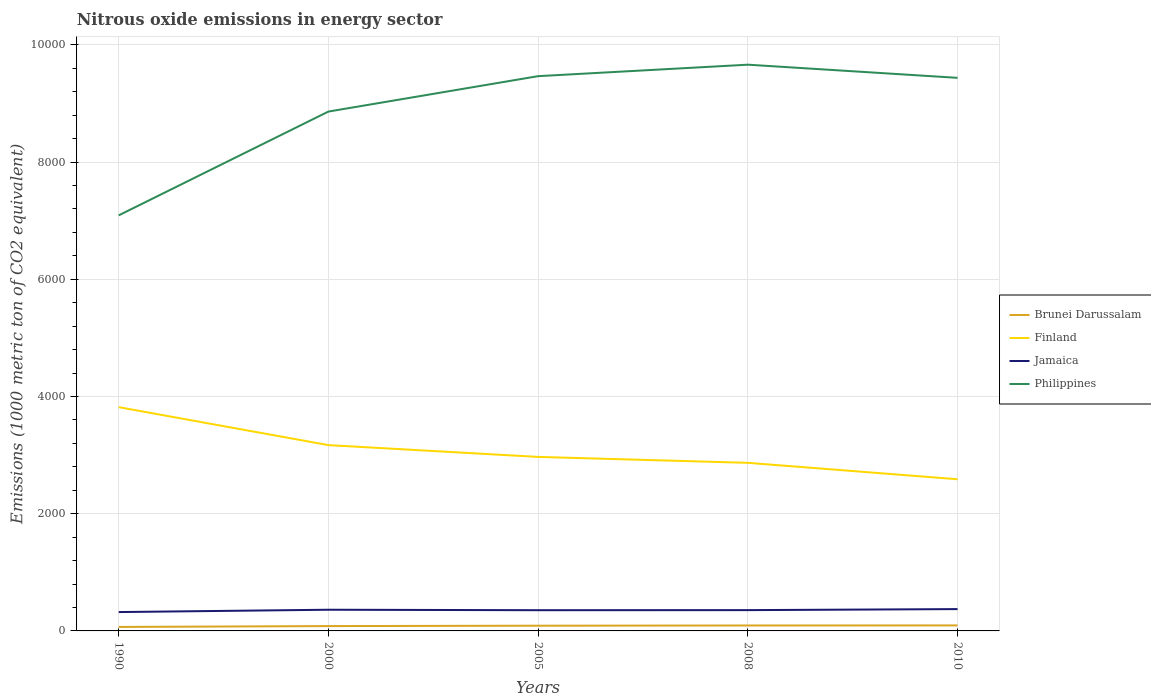Does the line corresponding to Jamaica intersect with the line corresponding to Philippines?
Offer a very short reply. No. Across all years, what is the maximum amount of nitrous oxide emitted in Philippines?
Your answer should be very brief. 7090.2. In which year was the amount of nitrous oxide emitted in Philippines maximum?
Make the answer very short. 1990. What is the total amount of nitrous oxide emitted in Philippines in the graph?
Your answer should be very brief. -1770.9. What is the difference between the highest and the second highest amount of nitrous oxide emitted in Brunei Darussalam?
Give a very brief answer. 26.2. What is the difference between the highest and the lowest amount of nitrous oxide emitted in Philippines?
Your answer should be very brief. 3. Is the amount of nitrous oxide emitted in Jamaica strictly greater than the amount of nitrous oxide emitted in Finland over the years?
Provide a short and direct response. Yes. How many lines are there?
Give a very brief answer. 4. What is the difference between two consecutive major ticks on the Y-axis?
Offer a very short reply. 2000. Does the graph contain grids?
Keep it short and to the point. Yes. How many legend labels are there?
Your answer should be compact. 4. What is the title of the graph?
Ensure brevity in your answer.  Nitrous oxide emissions in energy sector. What is the label or title of the Y-axis?
Your answer should be very brief. Emissions (1000 metric ton of CO2 equivalent). What is the Emissions (1000 metric ton of CO2 equivalent) of Brunei Darussalam in 1990?
Ensure brevity in your answer.  67.9. What is the Emissions (1000 metric ton of CO2 equivalent) in Finland in 1990?
Offer a terse response. 3817.9. What is the Emissions (1000 metric ton of CO2 equivalent) in Jamaica in 1990?
Your answer should be very brief. 321.7. What is the Emissions (1000 metric ton of CO2 equivalent) in Philippines in 1990?
Your response must be concise. 7090.2. What is the Emissions (1000 metric ton of CO2 equivalent) in Brunei Darussalam in 2000?
Your answer should be compact. 82.7. What is the Emissions (1000 metric ton of CO2 equivalent) of Finland in 2000?
Your answer should be very brief. 3169.9. What is the Emissions (1000 metric ton of CO2 equivalent) in Jamaica in 2000?
Your answer should be very brief. 361.6. What is the Emissions (1000 metric ton of CO2 equivalent) in Philippines in 2000?
Your answer should be compact. 8861.1. What is the Emissions (1000 metric ton of CO2 equivalent) in Brunei Darussalam in 2005?
Provide a short and direct response. 88.9. What is the Emissions (1000 metric ton of CO2 equivalent) in Finland in 2005?
Make the answer very short. 2969. What is the Emissions (1000 metric ton of CO2 equivalent) in Jamaica in 2005?
Your answer should be compact. 353.5. What is the Emissions (1000 metric ton of CO2 equivalent) in Philippines in 2005?
Your response must be concise. 9465.1. What is the Emissions (1000 metric ton of CO2 equivalent) of Brunei Darussalam in 2008?
Provide a short and direct response. 92.7. What is the Emissions (1000 metric ton of CO2 equivalent) of Finland in 2008?
Provide a succinct answer. 2868. What is the Emissions (1000 metric ton of CO2 equivalent) of Jamaica in 2008?
Provide a succinct answer. 354.8. What is the Emissions (1000 metric ton of CO2 equivalent) in Philippines in 2008?
Keep it short and to the point. 9660.8. What is the Emissions (1000 metric ton of CO2 equivalent) of Brunei Darussalam in 2010?
Offer a very short reply. 94.1. What is the Emissions (1000 metric ton of CO2 equivalent) in Finland in 2010?
Ensure brevity in your answer.  2587.6. What is the Emissions (1000 metric ton of CO2 equivalent) of Jamaica in 2010?
Offer a very short reply. 372.5. What is the Emissions (1000 metric ton of CO2 equivalent) in Philippines in 2010?
Provide a short and direct response. 9436.4. Across all years, what is the maximum Emissions (1000 metric ton of CO2 equivalent) of Brunei Darussalam?
Give a very brief answer. 94.1. Across all years, what is the maximum Emissions (1000 metric ton of CO2 equivalent) in Finland?
Provide a short and direct response. 3817.9. Across all years, what is the maximum Emissions (1000 metric ton of CO2 equivalent) in Jamaica?
Your response must be concise. 372.5. Across all years, what is the maximum Emissions (1000 metric ton of CO2 equivalent) of Philippines?
Your response must be concise. 9660.8. Across all years, what is the minimum Emissions (1000 metric ton of CO2 equivalent) in Brunei Darussalam?
Give a very brief answer. 67.9. Across all years, what is the minimum Emissions (1000 metric ton of CO2 equivalent) in Finland?
Provide a short and direct response. 2587.6. Across all years, what is the minimum Emissions (1000 metric ton of CO2 equivalent) of Jamaica?
Ensure brevity in your answer.  321.7. Across all years, what is the minimum Emissions (1000 metric ton of CO2 equivalent) in Philippines?
Offer a very short reply. 7090.2. What is the total Emissions (1000 metric ton of CO2 equivalent) of Brunei Darussalam in the graph?
Your answer should be compact. 426.3. What is the total Emissions (1000 metric ton of CO2 equivalent) of Finland in the graph?
Your response must be concise. 1.54e+04. What is the total Emissions (1000 metric ton of CO2 equivalent) of Jamaica in the graph?
Provide a short and direct response. 1764.1. What is the total Emissions (1000 metric ton of CO2 equivalent) of Philippines in the graph?
Ensure brevity in your answer.  4.45e+04. What is the difference between the Emissions (1000 metric ton of CO2 equivalent) in Brunei Darussalam in 1990 and that in 2000?
Keep it short and to the point. -14.8. What is the difference between the Emissions (1000 metric ton of CO2 equivalent) of Finland in 1990 and that in 2000?
Your answer should be very brief. 648. What is the difference between the Emissions (1000 metric ton of CO2 equivalent) in Jamaica in 1990 and that in 2000?
Give a very brief answer. -39.9. What is the difference between the Emissions (1000 metric ton of CO2 equivalent) in Philippines in 1990 and that in 2000?
Offer a terse response. -1770.9. What is the difference between the Emissions (1000 metric ton of CO2 equivalent) in Brunei Darussalam in 1990 and that in 2005?
Your answer should be very brief. -21. What is the difference between the Emissions (1000 metric ton of CO2 equivalent) of Finland in 1990 and that in 2005?
Offer a terse response. 848.9. What is the difference between the Emissions (1000 metric ton of CO2 equivalent) of Jamaica in 1990 and that in 2005?
Offer a terse response. -31.8. What is the difference between the Emissions (1000 metric ton of CO2 equivalent) in Philippines in 1990 and that in 2005?
Your answer should be very brief. -2374.9. What is the difference between the Emissions (1000 metric ton of CO2 equivalent) of Brunei Darussalam in 1990 and that in 2008?
Give a very brief answer. -24.8. What is the difference between the Emissions (1000 metric ton of CO2 equivalent) of Finland in 1990 and that in 2008?
Your answer should be compact. 949.9. What is the difference between the Emissions (1000 metric ton of CO2 equivalent) of Jamaica in 1990 and that in 2008?
Provide a succinct answer. -33.1. What is the difference between the Emissions (1000 metric ton of CO2 equivalent) in Philippines in 1990 and that in 2008?
Your answer should be compact. -2570.6. What is the difference between the Emissions (1000 metric ton of CO2 equivalent) in Brunei Darussalam in 1990 and that in 2010?
Your answer should be very brief. -26.2. What is the difference between the Emissions (1000 metric ton of CO2 equivalent) in Finland in 1990 and that in 2010?
Your response must be concise. 1230.3. What is the difference between the Emissions (1000 metric ton of CO2 equivalent) of Jamaica in 1990 and that in 2010?
Ensure brevity in your answer.  -50.8. What is the difference between the Emissions (1000 metric ton of CO2 equivalent) in Philippines in 1990 and that in 2010?
Offer a terse response. -2346.2. What is the difference between the Emissions (1000 metric ton of CO2 equivalent) of Brunei Darussalam in 2000 and that in 2005?
Your answer should be very brief. -6.2. What is the difference between the Emissions (1000 metric ton of CO2 equivalent) of Finland in 2000 and that in 2005?
Keep it short and to the point. 200.9. What is the difference between the Emissions (1000 metric ton of CO2 equivalent) in Philippines in 2000 and that in 2005?
Your response must be concise. -604. What is the difference between the Emissions (1000 metric ton of CO2 equivalent) of Finland in 2000 and that in 2008?
Your answer should be very brief. 301.9. What is the difference between the Emissions (1000 metric ton of CO2 equivalent) in Philippines in 2000 and that in 2008?
Your answer should be very brief. -799.7. What is the difference between the Emissions (1000 metric ton of CO2 equivalent) of Finland in 2000 and that in 2010?
Offer a terse response. 582.3. What is the difference between the Emissions (1000 metric ton of CO2 equivalent) in Jamaica in 2000 and that in 2010?
Offer a very short reply. -10.9. What is the difference between the Emissions (1000 metric ton of CO2 equivalent) in Philippines in 2000 and that in 2010?
Make the answer very short. -575.3. What is the difference between the Emissions (1000 metric ton of CO2 equivalent) of Finland in 2005 and that in 2008?
Ensure brevity in your answer.  101. What is the difference between the Emissions (1000 metric ton of CO2 equivalent) in Jamaica in 2005 and that in 2008?
Offer a very short reply. -1.3. What is the difference between the Emissions (1000 metric ton of CO2 equivalent) of Philippines in 2005 and that in 2008?
Your answer should be very brief. -195.7. What is the difference between the Emissions (1000 metric ton of CO2 equivalent) of Brunei Darussalam in 2005 and that in 2010?
Provide a succinct answer. -5.2. What is the difference between the Emissions (1000 metric ton of CO2 equivalent) of Finland in 2005 and that in 2010?
Ensure brevity in your answer.  381.4. What is the difference between the Emissions (1000 metric ton of CO2 equivalent) of Jamaica in 2005 and that in 2010?
Offer a terse response. -19. What is the difference between the Emissions (1000 metric ton of CO2 equivalent) of Philippines in 2005 and that in 2010?
Offer a terse response. 28.7. What is the difference between the Emissions (1000 metric ton of CO2 equivalent) in Brunei Darussalam in 2008 and that in 2010?
Offer a terse response. -1.4. What is the difference between the Emissions (1000 metric ton of CO2 equivalent) in Finland in 2008 and that in 2010?
Make the answer very short. 280.4. What is the difference between the Emissions (1000 metric ton of CO2 equivalent) in Jamaica in 2008 and that in 2010?
Ensure brevity in your answer.  -17.7. What is the difference between the Emissions (1000 metric ton of CO2 equivalent) in Philippines in 2008 and that in 2010?
Provide a succinct answer. 224.4. What is the difference between the Emissions (1000 metric ton of CO2 equivalent) in Brunei Darussalam in 1990 and the Emissions (1000 metric ton of CO2 equivalent) in Finland in 2000?
Keep it short and to the point. -3102. What is the difference between the Emissions (1000 metric ton of CO2 equivalent) of Brunei Darussalam in 1990 and the Emissions (1000 metric ton of CO2 equivalent) of Jamaica in 2000?
Your answer should be very brief. -293.7. What is the difference between the Emissions (1000 metric ton of CO2 equivalent) of Brunei Darussalam in 1990 and the Emissions (1000 metric ton of CO2 equivalent) of Philippines in 2000?
Keep it short and to the point. -8793.2. What is the difference between the Emissions (1000 metric ton of CO2 equivalent) in Finland in 1990 and the Emissions (1000 metric ton of CO2 equivalent) in Jamaica in 2000?
Offer a terse response. 3456.3. What is the difference between the Emissions (1000 metric ton of CO2 equivalent) of Finland in 1990 and the Emissions (1000 metric ton of CO2 equivalent) of Philippines in 2000?
Keep it short and to the point. -5043.2. What is the difference between the Emissions (1000 metric ton of CO2 equivalent) in Jamaica in 1990 and the Emissions (1000 metric ton of CO2 equivalent) in Philippines in 2000?
Keep it short and to the point. -8539.4. What is the difference between the Emissions (1000 metric ton of CO2 equivalent) of Brunei Darussalam in 1990 and the Emissions (1000 metric ton of CO2 equivalent) of Finland in 2005?
Offer a very short reply. -2901.1. What is the difference between the Emissions (1000 metric ton of CO2 equivalent) of Brunei Darussalam in 1990 and the Emissions (1000 metric ton of CO2 equivalent) of Jamaica in 2005?
Give a very brief answer. -285.6. What is the difference between the Emissions (1000 metric ton of CO2 equivalent) in Brunei Darussalam in 1990 and the Emissions (1000 metric ton of CO2 equivalent) in Philippines in 2005?
Offer a very short reply. -9397.2. What is the difference between the Emissions (1000 metric ton of CO2 equivalent) of Finland in 1990 and the Emissions (1000 metric ton of CO2 equivalent) of Jamaica in 2005?
Provide a succinct answer. 3464.4. What is the difference between the Emissions (1000 metric ton of CO2 equivalent) of Finland in 1990 and the Emissions (1000 metric ton of CO2 equivalent) of Philippines in 2005?
Your response must be concise. -5647.2. What is the difference between the Emissions (1000 metric ton of CO2 equivalent) in Jamaica in 1990 and the Emissions (1000 metric ton of CO2 equivalent) in Philippines in 2005?
Your answer should be compact. -9143.4. What is the difference between the Emissions (1000 metric ton of CO2 equivalent) of Brunei Darussalam in 1990 and the Emissions (1000 metric ton of CO2 equivalent) of Finland in 2008?
Ensure brevity in your answer.  -2800.1. What is the difference between the Emissions (1000 metric ton of CO2 equivalent) in Brunei Darussalam in 1990 and the Emissions (1000 metric ton of CO2 equivalent) in Jamaica in 2008?
Offer a terse response. -286.9. What is the difference between the Emissions (1000 metric ton of CO2 equivalent) in Brunei Darussalam in 1990 and the Emissions (1000 metric ton of CO2 equivalent) in Philippines in 2008?
Give a very brief answer. -9592.9. What is the difference between the Emissions (1000 metric ton of CO2 equivalent) in Finland in 1990 and the Emissions (1000 metric ton of CO2 equivalent) in Jamaica in 2008?
Make the answer very short. 3463.1. What is the difference between the Emissions (1000 metric ton of CO2 equivalent) of Finland in 1990 and the Emissions (1000 metric ton of CO2 equivalent) of Philippines in 2008?
Make the answer very short. -5842.9. What is the difference between the Emissions (1000 metric ton of CO2 equivalent) of Jamaica in 1990 and the Emissions (1000 metric ton of CO2 equivalent) of Philippines in 2008?
Make the answer very short. -9339.1. What is the difference between the Emissions (1000 metric ton of CO2 equivalent) in Brunei Darussalam in 1990 and the Emissions (1000 metric ton of CO2 equivalent) in Finland in 2010?
Make the answer very short. -2519.7. What is the difference between the Emissions (1000 metric ton of CO2 equivalent) in Brunei Darussalam in 1990 and the Emissions (1000 metric ton of CO2 equivalent) in Jamaica in 2010?
Provide a short and direct response. -304.6. What is the difference between the Emissions (1000 metric ton of CO2 equivalent) of Brunei Darussalam in 1990 and the Emissions (1000 metric ton of CO2 equivalent) of Philippines in 2010?
Provide a succinct answer. -9368.5. What is the difference between the Emissions (1000 metric ton of CO2 equivalent) in Finland in 1990 and the Emissions (1000 metric ton of CO2 equivalent) in Jamaica in 2010?
Give a very brief answer. 3445.4. What is the difference between the Emissions (1000 metric ton of CO2 equivalent) of Finland in 1990 and the Emissions (1000 metric ton of CO2 equivalent) of Philippines in 2010?
Make the answer very short. -5618.5. What is the difference between the Emissions (1000 metric ton of CO2 equivalent) of Jamaica in 1990 and the Emissions (1000 metric ton of CO2 equivalent) of Philippines in 2010?
Ensure brevity in your answer.  -9114.7. What is the difference between the Emissions (1000 metric ton of CO2 equivalent) in Brunei Darussalam in 2000 and the Emissions (1000 metric ton of CO2 equivalent) in Finland in 2005?
Ensure brevity in your answer.  -2886.3. What is the difference between the Emissions (1000 metric ton of CO2 equivalent) of Brunei Darussalam in 2000 and the Emissions (1000 metric ton of CO2 equivalent) of Jamaica in 2005?
Provide a short and direct response. -270.8. What is the difference between the Emissions (1000 metric ton of CO2 equivalent) of Brunei Darussalam in 2000 and the Emissions (1000 metric ton of CO2 equivalent) of Philippines in 2005?
Give a very brief answer. -9382.4. What is the difference between the Emissions (1000 metric ton of CO2 equivalent) in Finland in 2000 and the Emissions (1000 metric ton of CO2 equivalent) in Jamaica in 2005?
Give a very brief answer. 2816.4. What is the difference between the Emissions (1000 metric ton of CO2 equivalent) of Finland in 2000 and the Emissions (1000 metric ton of CO2 equivalent) of Philippines in 2005?
Give a very brief answer. -6295.2. What is the difference between the Emissions (1000 metric ton of CO2 equivalent) in Jamaica in 2000 and the Emissions (1000 metric ton of CO2 equivalent) in Philippines in 2005?
Provide a succinct answer. -9103.5. What is the difference between the Emissions (1000 metric ton of CO2 equivalent) in Brunei Darussalam in 2000 and the Emissions (1000 metric ton of CO2 equivalent) in Finland in 2008?
Make the answer very short. -2785.3. What is the difference between the Emissions (1000 metric ton of CO2 equivalent) of Brunei Darussalam in 2000 and the Emissions (1000 metric ton of CO2 equivalent) of Jamaica in 2008?
Give a very brief answer. -272.1. What is the difference between the Emissions (1000 metric ton of CO2 equivalent) of Brunei Darussalam in 2000 and the Emissions (1000 metric ton of CO2 equivalent) of Philippines in 2008?
Offer a very short reply. -9578.1. What is the difference between the Emissions (1000 metric ton of CO2 equivalent) of Finland in 2000 and the Emissions (1000 metric ton of CO2 equivalent) of Jamaica in 2008?
Your answer should be very brief. 2815.1. What is the difference between the Emissions (1000 metric ton of CO2 equivalent) in Finland in 2000 and the Emissions (1000 metric ton of CO2 equivalent) in Philippines in 2008?
Your response must be concise. -6490.9. What is the difference between the Emissions (1000 metric ton of CO2 equivalent) in Jamaica in 2000 and the Emissions (1000 metric ton of CO2 equivalent) in Philippines in 2008?
Provide a short and direct response. -9299.2. What is the difference between the Emissions (1000 metric ton of CO2 equivalent) of Brunei Darussalam in 2000 and the Emissions (1000 metric ton of CO2 equivalent) of Finland in 2010?
Your response must be concise. -2504.9. What is the difference between the Emissions (1000 metric ton of CO2 equivalent) of Brunei Darussalam in 2000 and the Emissions (1000 metric ton of CO2 equivalent) of Jamaica in 2010?
Your answer should be very brief. -289.8. What is the difference between the Emissions (1000 metric ton of CO2 equivalent) of Brunei Darussalam in 2000 and the Emissions (1000 metric ton of CO2 equivalent) of Philippines in 2010?
Provide a short and direct response. -9353.7. What is the difference between the Emissions (1000 metric ton of CO2 equivalent) in Finland in 2000 and the Emissions (1000 metric ton of CO2 equivalent) in Jamaica in 2010?
Ensure brevity in your answer.  2797.4. What is the difference between the Emissions (1000 metric ton of CO2 equivalent) in Finland in 2000 and the Emissions (1000 metric ton of CO2 equivalent) in Philippines in 2010?
Provide a succinct answer. -6266.5. What is the difference between the Emissions (1000 metric ton of CO2 equivalent) of Jamaica in 2000 and the Emissions (1000 metric ton of CO2 equivalent) of Philippines in 2010?
Offer a terse response. -9074.8. What is the difference between the Emissions (1000 metric ton of CO2 equivalent) of Brunei Darussalam in 2005 and the Emissions (1000 metric ton of CO2 equivalent) of Finland in 2008?
Keep it short and to the point. -2779.1. What is the difference between the Emissions (1000 metric ton of CO2 equivalent) of Brunei Darussalam in 2005 and the Emissions (1000 metric ton of CO2 equivalent) of Jamaica in 2008?
Ensure brevity in your answer.  -265.9. What is the difference between the Emissions (1000 metric ton of CO2 equivalent) in Brunei Darussalam in 2005 and the Emissions (1000 metric ton of CO2 equivalent) in Philippines in 2008?
Provide a short and direct response. -9571.9. What is the difference between the Emissions (1000 metric ton of CO2 equivalent) of Finland in 2005 and the Emissions (1000 metric ton of CO2 equivalent) of Jamaica in 2008?
Offer a very short reply. 2614.2. What is the difference between the Emissions (1000 metric ton of CO2 equivalent) in Finland in 2005 and the Emissions (1000 metric ton of CO2 equivalent) in Philippines in 2008?
Ensure brevity in your answer.  -6691.8. What is the difference between the Emissions (1000 metric ton of CO2 equivalent) of Jamaica in 2005 and the Emissions (1000 metric ton of CO2 equivalent) of Philippines in 2008?
Keep it short and to the point. -9307.3. What is the difference between the Emissions (1000 metric ton of CO2 equivalent) of Brunei Darussalam in 2005 and the Emissions (1000 metric ton of CO2 equivalent) of Finland in 2010?
Give a very brief answer. -2498.7. What is the difference between the Emissions (1000 metric ton of CO2 equivalent) of Brunei Darussalam in 2005 and the Emissions (1000 metric ton of CO2 equivalent) of Jamaica in 2010?
Provide a short and direct response. -283.6. What is the difference between the Emissions (1000 metric ton of CO2 equivalent) in Brunei Darussalam in 2005 and the Emissions (1000 metric ton of CO2 equivalent) in Philippines in 2010?
Provide a succinct answer. -9347.5. What is the difference between the Emissions (1000 metric ton of CO2 equivalent) of Finland in 2005 and the Emissions (1000 metric ton of CO2 equivalent) of Jamaica in 2010?
Make the answer very short. 2596.5. What is the difference between the Emissions (1000 metric ton of CO2 equivalent) of Finland in 2005 and the Emissions (1000 metric ton of CO2 equivalent) of Philippines in 2010?
Provide a short and direct response. -6467.4. What is the difference between the Emissions (1000 metric ton of CO2 equivalent) of Jamaica in 2005 and the Emissions (1000 metric ton of CO2 equivalent) of Philippines in 2010?
Offer a terse response. -9082.9. What is the difference between the Emissions (1000 metric ton of CO2 equivalent) of Brunei Darussalam in 2008 and the Emissions (1000 metric ton of CO2 equivalent) of Finland in 2010?
Your response must be concise. -2494.9. What is the difference between the Emissions (1000 metric ton of CO2 equivalent) of Brunei Darussalam in 2008 and the Emissions (1000 metric ton of CO2 equivalent) of Jamaica in 2010?
Provide a succinct answer. -279.8. What is the difference between the Emissions (1000 metric ton of CO2 equivalent) in Brunei Darussalam in 2008 and the Emissions (1000 metric ton of CO2 equivalent) in Philippines in 2010?
Ensure brevity in your answer.  -9343.7. What is the difference between the Emissions (1000 metric ton of CO2 equivalent) in Finland in 2008 and the Emissions (1000 metric ton of CO2 equivalent) in Jamaica in 2010?
Offer a terse response. 2495.5. What is the difference between the Emissions (1000 metric ton of CO2 equivalent) in Finland in 2008 and the Emissions (1000 metric ton of CO2 equivalent) in Philippines in 2010?
Provide a succinct answer. -6568.4. What is the difference between the Emissions (1000 metric ton of CO2 equivalent) in Jamaica in 2008 and the Emissions (1000 metric ton of CO2 equivalent) in Philippines in 2010?
Your answer should be very brief. -9081.6. What is the average Emissions (1000 metric ton of CO2 equivalent) in Brunei Darussalam per year?
Provide a succinct answer. 85.26. What is the average Emissions (1000 metric ton of CO2 equivalent) of Finland per year?
Make the answer very short. 3082.48. What is the average Emissions (1000 metric ton of CO2 equivalent) in Jamaica per year?
Your answer should be compact. 352.82. What is the average Emissions (1000 metric ton of CO2 equivalent) of Philippines per year?
Offer a terse response. 8902.72. In the year 1990, what is the difference between the Emissions (1000 metric ton of CO2 equivalent) of Brunei Darussalam and Emissions (1000 metric ton of CO2 equivalent) of Finland?
Ensure brevity in your answer.  -3750. In the year 1990, what is the difference between the Emissions (1000 metric ton of CO2 equivalent) of Brunei Darussalam and Emissions (1000 metric ton of CO2 equivalent) of Jamaica?
Make the answer very short. -253.8. In the year 1990, what is the difference between the Emissions (1000 metric ton of CO2 equivalent) in Brunei Darussalam and Emissions (1000 metric ton of CO2 equivalent) in Philippines?
Ensure brevity in your answer.  -7022.3. In the year 1990, what is the difference between the Emissions (1000 metric ton of CO2 equivalent) of Finland and Emissions (1000 metric ton of CO2 equivalent) of Jamaica?
Provide a short and direct response. 3496.2. In the year 1990, what is the difference between the Emissions (1000 metric ton of CO2 equivalent) of Finland and Emissions (1000 metric ton of CO2 equivalent) of Philippines?
Keep it short and to the point. -3272.3. In the year 1990, what is the difference between the Emissions (1000 metric ton of CO2 equivalent) of Jamaica and Emissions (1000 metric ton of CO2 equivalent) of Philippines?
Ensure brevity in your answer.  -6768.5. In the year 2000, what is the difference between the Emissions (1000 metric ton of CO2 equivalent) in Brunei Darussalam and Emissions (1000 metric ton of CO2 equivalent) in Finland?
Ensure brevity in your answer.  -3087.2. In the year 2000, what is the difference between the Emissions (1000 metric ton of CO2 equivalent) in Brunei Darussalam and Emissions (1000 metric ton of CO2 equivalent) in Jamaica?
Your answer should be compact. -278.9. In the year 2000, what is the difference between the Emissions (1000 metric ton of CO2 equivalent) in Brunei Darussalam and Emissions (1000 metric ton of CO2 equivalent) in Philippines?
Give a very brief answer. -8778.4. In the year 2000, what is the difference between the Emissions (1000 metric ton of CO2 equivalent) in Finland and Emissions (1000 metric ton of CO2 equivalent) in Jamaica?
Offer a very short reply. 2808.3. In the year 2000, what is the difference between the Emissions (1000 metric ton of CO2 equivalent) of Finland and Emissions (1000 metric ton of CO2 equivalent) of Philippines?
Make the answer very short. -5691.2. In the year 2000, what is the difference between the Emissions (1000 metric ton of CO2 equivalent) of Jamaica and Emissions (1000 metric ton of CO2 equivalent) of Philippines?
Provide a short and direct response. -8499.5. In the year 2005, what is the difference between the Emissions (1000 metric ton of CO2 equivalent) in Brunei Darussalam and Emissions (1000 metric ton of CO2 equivalent) in Finland?
Keep it short and to the point. -2880.1. In the year 2005, what is the difference between the Emissions (1000 metric ton of CO2 equivalent) of Brunei Darussalam and Emissions (1000 metric ton of CO2 equivalent) of Jamaica?
Give a very brief answer. -264.6. In the year 2005, what is the difference between the Emissions (1000 metric ton of CO2 equivalent) in Brunei Darussalam and Emissions (1000 metric ton of CO2 equivalent) in Philippines?
Provide a short and direct response. -9376.2. In the year 2005, what is the difference between the Emissions (1000 metric ton of CO2 equivalent) of Finland and Emissions (1000 metric ton of CO2 equivalent) of Jamaica?
Offer a terse response. 2615.5. In the year 2005, what is the difference between the Emissions (1000 metric ton of CO2 equivalent) in Finland and Emissions (1000 metric ton of CO2 equivalent) in Philippines?
Offer a very short reply. -6496.1. In the year 2005, what is the difference between the Emissions (1000 metric ton of CO2 equivalent) in Jamaica and Emissions (1000 metric ton of CO2 equivalent) in Philippines?
Offer a very short reply. -9111.6. In the year 2008, what is the difference between the Emissions (1000 metric ton of CO2 equivalent) of Brunei Darussalam and Emissions (1000 metric ton of CO2 equivalent) of Finland?
Offer a terse response. -2775.3. In the year 2008, what is the difference between the Emissions (1000 metric ton of CO2 equivalent) in Brunei Darussalam and Emissions (1000 metric ton of CO2 equivalent) in Jamaica?
Your response must be concise. -262.1. In the year 2008, what is the difference between the Emissions (1000 metric ton of CO2 equivalent) in Brunei Darussalam and Emissions (1000 metric ton of CO2 equivalent) in Philippines?
Give a very brief answer. -9568.1. In the year 2008, what is the difference between the Emissions (1000 metric ton of CO2 equivalent) of Finland and Emissions (1000 metric ton of CO2 equivalent) of Jamaica?
Your answer should be compact. 2513.2. In the year 2008, what is the difference between the Emissions (1000 metric ton of CO2 equivalent) of Finland and Emissions (1000 metric ton of CO2 equivalent) of Philippines?
Make the answer very short. -6792.8. In the year 2008, what is the difference between the Emissions (1000 metric ton of CO2 equivalent) in Jamaica and Emissions (1000 metric ton of CO2 equivalent) in Philippines?
Ensure brevity in your answer.  -9306. In the year 2010, what is the difference between the Emissions (1000 metric ton of CO2 equivalent) in Brunei Darussalam and Emissions (1000 metric ton of CO2 equivalent) in Finland?
Offer a very short reply. -2493.5. In the year 2010, what is the difference between the Emissions (1000 metric ton of CO2 equivalent) of Brunei Darussalam and Emissions (1000 metric ton of CO2 equivalent) of Jamaica?
Provide a short and direct response. -278.4. In the year 2010, what is the difference between the Emissions (1000 metric ton of CO2 equivalent) of Brunei Darussalam and Emissions (1000 metric ton of CO2 equivalent) of Philippines?
Provide a short and direct response. -9342.3. In the year 2010, what is the difference between the Emissions (1000 metric ton of CO2 equivalent) in Finland and Emissions (1000 metric ton of CO2 equivalent) in Jamaica?
Offer a terse response. 2215.1. In the year 2010, what is the difference between the Emissions (1000 metric ton of CO2 equivalent) in Finland and Emissions (1000 metric ton of CO2 equivalent) in Philippines?
Give a very brief answer. -6848.8. In the year 2010, what is the difference between the Emissions (1000 metric ton of CO2 equivalent) in Jamaica and Emissions (1000 metric ton of CO2 equivalent) in Philippines?
Provide a succinct answer. -9063.9. What is the ratio of the Emissions (1000 metric ton of CO2 equivalent) in Brunei Darussalam in 1990 to that in 2000?
Offer a very short reply. 0.82. What is the ratio of the Emissions (1000 metric ton of CO2 equivalent) in Finland in 1990 to that in 2000?
Provide a short and direct response. 1.2. What is the ratio of the Emissions (1000 metric ton of CO2 equivalent) of Jamaica in 1990 to that in 2000?
Ensure brevity in your answer.  0.89. What is the ratio of the Emissions (1000 metric ton of CO2 equivalent) of Philippines in 1990 to that in 2000?
Keep it short and to the point. 0.8. What is the ratio of the Emissions (1000 metric ton of CO2 equivalent) in Brunei Darussalam in 1990 to that in 2005?
Provide a succinct answer. 0.76. What is the ratio of the Emissions (1000 metric ton of CO2 equivalent) in Finland in 1990 to that in 2005?
Offer a terse response. 1.29. What is the ratio of the Emissions (1000 metric ton of CO2 equivalent) in Jamaica in 1990 to that in 2005?
Your answer should be compact. 0.91. What is the ratio of the Emissions (1000 metric ton of CO2 equivalent) of Philippines in 1990 to that in 2005?
Give a very brief answer. 0.75. What is the ratio of the Emissions (1000 metric ton of CO2 equivalent) of Brunei Darussalam in 1990 to that in 2008?
Provide a succinct answer. 0.73. What is the ratio of the Emissions (1000 metric ton of CO2 equivalent) in Finland in 1990 to that in 2008?
Make the answer very short. 1.33. What is the ratio of the Emissions (1000 metric ton of CO2 equivalent) of Jamaica in 1990 to that in 2008?
Offer a very short reply. 0.91. What is the ratio of the Emissions (1000 metric ton of CO2 equivalent) in Philippines in 1990 to that in 2008?
Provide a succinct answer. 0.73. What is the ratio of the Emissions (1000 metric ton of CO2 equivalent) in Brunei Darussalam in 1990 to that in 2010?
Provide a succinct answer. 0.72. What is the ratio of the Emissions (1000 metric ton of CO2 equivalent) in Finland in 1990 to that in 2010?
Provide a succinct answer. 1.48. What is the ratio of the Emissions (1000 metric ton of CO2 equivalent) of Jamaica in 1990 to that in 2010?
Your answer should be compact. 0.86. What is the ratio of the Emissions (1000 metric ton of CO2 equivalent) in Philippines in 1990 to that in 2010?
Your answer should be compact. 0.75. What is the ratio of the Emissions (1000 metric ton of CO2 equivalent) in Brunei Darussalam in 2000 to that in 2005?
Offer a terse response. 0.93. What is the ratio of the Emissions (1000 metric ton of CO2 equivalent) in Finland in 2000 to that in 2005?
Provide a succinct answer. 1.07. What is the ratio of the Emissions (1000 metric ton of CO2 equivalent) of Jamaica in 2000 to that in 2005?
Provide a short and direct response. 1.02. What is the ratio of the Emissions (1000 metric ton of CO2 equivalent) in Philippines in 2000 to that in 2005?
Provide a succinct answer. 0.94. What is the ratio of the Emissions (1000 metric ton of CO2 equivalent) of Brunei Darussalam in 2000 to that in 2008?
Your answer should be compact. 0.89. What is the ratio of the Emissions (1000 metric ton of CO2 equivalent) of Finland in 2000 to that in 2008?
Provide a succinct answer. 1.11. What is the ratio of the Emissions (1000 metric ton of CO2 equivalent) of Jamaica in 2000 to that in 2008?
Provide a short and direct response. 1.02. What is the ratio of the Emissions (1000 metric ton of CO2 equivalent) of Philippines in 2000 to that in 2008?
Provide a short and direct response. 0.92. What is the ratio of the Emissions (1000 metric ton of CO2 equivalent) in Brunei Darussalam in 2000 to that in 2010?
Offer a terse response. 0.88. What is the ratio of the Emissions (1000 metric ton of CO2 equivalent) in Finland in 2000 to that in 2010?
Give a very brief answer. 1.23. What is the ratio of the Emissions (1000 metric ton of CO2 equivalent) of Jamaica in 2000 to that in 2010?
Provide a short and direct response. 0.97. What is the ratio of the Emissions (1000 metric ton of CO2 equivalent) in Philippines in 2000 to that in 2010?
Keep it short and to the point. 0.94. What is the ratio of the Emissions (1000 metric ton of CO2 equivalent) in Finland in 2005 to that in 2008?
Give a very brief answer. 1.04. What is the ratio of the Emissions (1000 metric ton of CO2 equivalent) of Jamaica in 2005 to that in 2008?
Offer a terse response. 1. What is the ratio of the Emissions (1000 metric ton of CO2 equivalent) of Philippines in 2005 to that in 2008?
Your response must be concise. 0.98. What is the ratio of the Emissions (1000 metric ton of CO2 equivalent) in Brunei Darussalam in 2005 to that in 2010?
Keep it short and to the point. 0.94. What is the ratio of the Emissions (1000 metric ton of CO2 equivalent) of Finland in 2005 to that in 2010?
Your response must be concise. 1.15. What is the ratio of the Emissions (1000 metric ton of CO2 equivalent) in Jamaica in 2005 to that in 2010?
Your answer should be compact. 0.95. What is the ratio of the Emissions (1000 metric ton of CO2 equivalent) in Philippines in 2005 to that in 2010?
Your response must be concise. 1. What is the ratio of the Emissions (1000 metric ton of CO2 equivalent) of Brunei Darussalam in 2008 to that in 2010?
Your answer should be compact. 0.99. What is the ratio of the Emissions (1000 metric ton of CO2 equivalent) of Finland in 2008 to that in 2010?
Offer a terse response. 1.11. What is the ratio of the Emissions (1000 metric ton of CO2 equivalent) in Jamaica in 2008 to that in 2010?
Your answer should be very brief. 0.95. What is the ratio of the Emissions (1000 metric ton of CO2 equivalent) in Philippines in 2008 to that in 2010?
Ensure brevity in your answer.  1.02. What is the difference between the highest and the second highest Emissions (1000 metric ton of CO2 equivalent) in Finland?
Provide a succinct answer. 648. What is the difference between the highest and the second highest Emissions (1000 metric ton of CO2 equivalent) of Jamaica?
Your answer should be very brief. 10.9. What is the difference between the highest and the second highest Emissions (1000 metric ton of CO2 equivalent) of Philippines?
Offer a terse response. 195.7. What is the difference between the highest and the lowest Emissions (1000 metric ton of CO2 equivalent) in Brunei Darussalam?
Keep it short and to the point. 26.2. What is the difference between the highest and the lowest Emissions (1000 metric ton of CO2 equivalent) in Finland?
Provide a succinct answer. 1230.3. What is the difference between the highest and the lowest Emissions (1000 metric ton of CO2 equivalent) in Jamaica?
Your answer should be compact. 50.8. What is the difference between the highest and the lowest Emissions (1000 metric ton of CO2 equivalent) in Philippines?
Your answer should be very brief. 2570.6. 